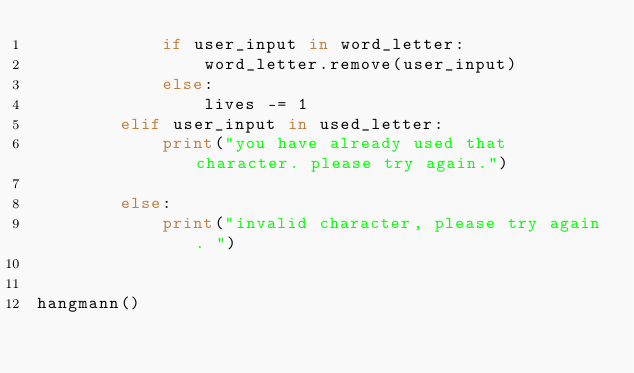<code> <loc_0><loc_0><loc_500><loc_500><_Python_>            if user_input in word_letter:
                word_letter.remove(user_input)
            else:
                lives -= 1
        elif user_input in used_letter:
            print("you have already used that character. please try again.")

        else:
            print("invalid character, please try again. ")


hangmann()
</code> 